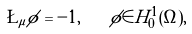Convert formula to latex. <formula><loc_0><loc_0><loc_500><loc_500>\L _ { \mu } \phi = - 1 , \quad \phi \in H ^ { 1 } _ { 0 } ( \Omega ) ,</formula> 